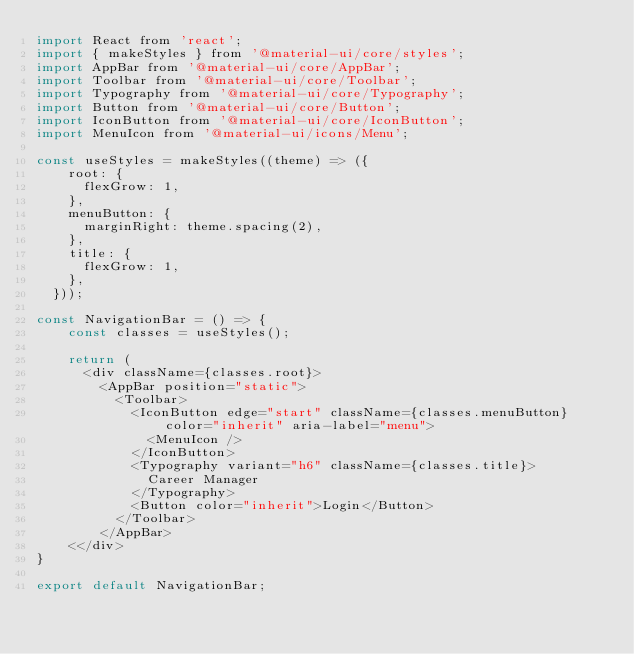<code> <loc_0><loc_0><loc_500><loc_500><_JavaScript_>import React from 'react';
import { makeStyles } from '@material-ui/core/styles';
import AppBar from '@material-ui/core/AppBar';
import Toolbar from '@material-ui/core/Toolbar';
import Typography from '@material-ui/core/Typography';
import Button from '@material-ui/core/Button';
import IconButton from '@material-ui/core/IconButton';
import MenuIcon from '@material-ui/icons/Menu';

const useStyles = makeStyles((theme) => ({
    root: {
      flexGrow: 1,
    },
    menuButton: {
      marginRight: theme.spacing(2),
    },
    title: {
      flexGrow: 1,
    },
  }));

const NavigationBar = () => {
    const classes = useStyles();

    return (
      <div className={classes.root}>
        <AppBar position="static">
          <Toolbar>
            <IconButton edge="start" className={classes.menuButton} color="inherit" aria-label="menu">
              <MenuIcon />
            </IconButton>
            <Typography variant="h6" className={classes.title}>
              Career Manager
            </Typography>
            <Button color="inherit">Login</Button>
          </Toolbar>
        </AppBar>
    <</div>
}

export default NavigationBar;</code> 